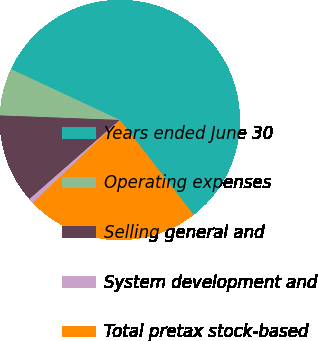Convert chart to OTSL. <chart><loc_0><loc_0><loc_500><loc_500><pie_chart><fcel>Years ended June 30<fcel>Operating expenses<fcel>Selling general and<fcel>System development and<fcel>Total pretax stock-based<nl><fcel>57.53%<fcel>6.35%<fcel>12.04%<fcel>0.67%<fcel>23.41%<nl></chart> 